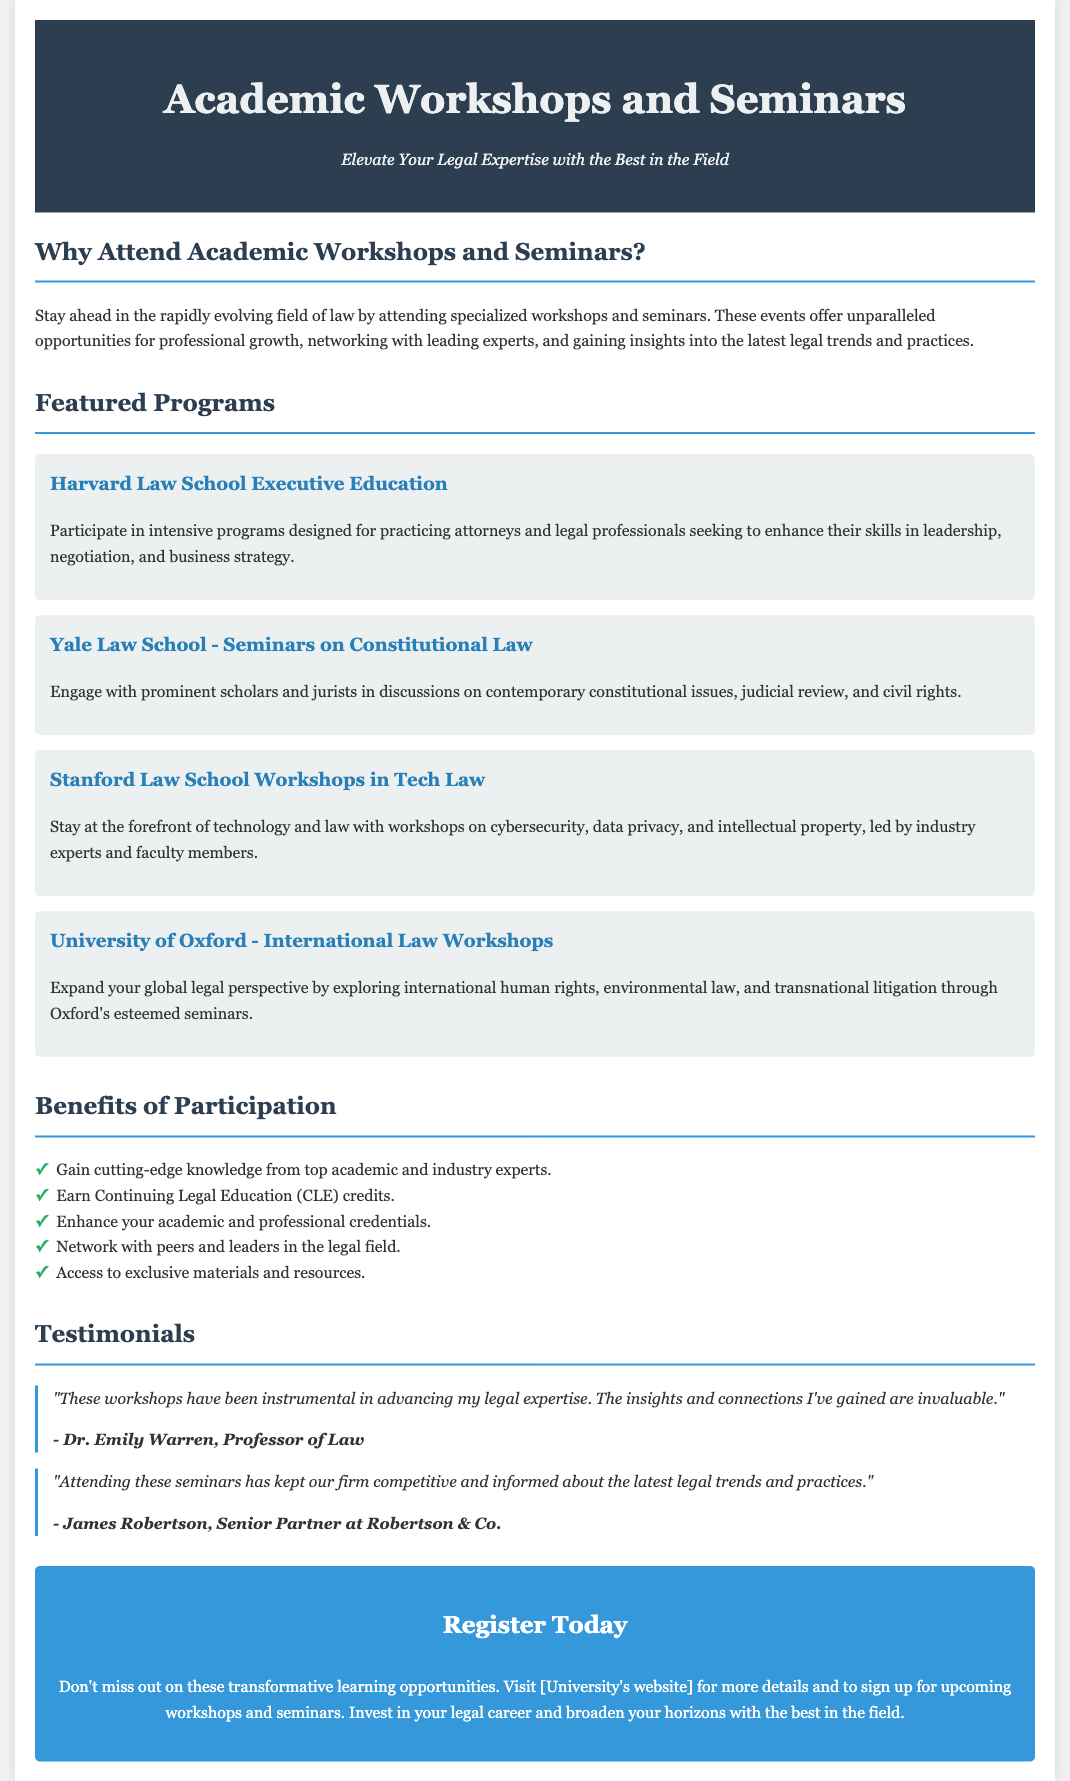What is the title of the flyer? The title of the flyer is prominently displayed at the top of the document.
Answer: Academic Workshops and Seminars What are the featured programs mentioned? The featured programs are outlined in separate sections, providing titles and brief descriptions.
Answer: Harvard Law School Executive Education, Yale Law School - Seminars on Constitutional Law, Stanford Law School Workshops in Tech Law, University of Oxford - International Law Workshops What benefit is listed regarding Continuing Legal Education? The document mentions a specific benefit related to Continuing Legal Education.
Answer: Earn Continuing Legal Education (CLE) credits Who provided a testimonial praising the workshops? The document includes testimonials that mention individuals who have benefited from the workshops.
Answer: Dr. Emily Warren, Professor of Law What are the main topics covered by the Stanford Law School workshops? The specifics of the workshop focus are highlighted in the description of the program.
Answer: Cybersecurity, data privacy, and intellectual property Why should one invest in their legal career according to the flyer? The flyer encourages participation by highlighting the transformative nature of the workshops.
Answer: Transformative learning opportunities How can participants register for the workshops? The document provides a call-to-action for registration and reference to further details.
Answer: Visit [University's website] 